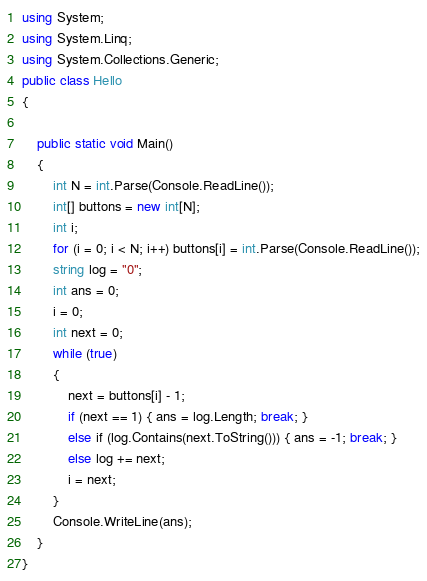<code> <loc_0><loc_0><loc_500><loc_500><_C#_>using System;
using System.Linq;
using System.Collections.Generic;
public class Hello
{

    public static void Main()
    {
        int N = int.Parse(Console.ReadLine());
        int[] buttons = new int[N];
        int i;
        for (i = 0; i < N; i++) buttons[i] = int.Parse(Console.ReadLine());
        string log = "0";
        int ans = 0;
        i = 0;
        int next = 0;
        while (true)
        {
            next = buttons[i] - 1;
            if (next == 1) { ans = log.Length; break; }
            else if (log.Contains(next.ToString())) { ans = -1; break; }
            else log += next;
            i = next;
        }
        Console.WriteLine(ans);
    }
}</code> 